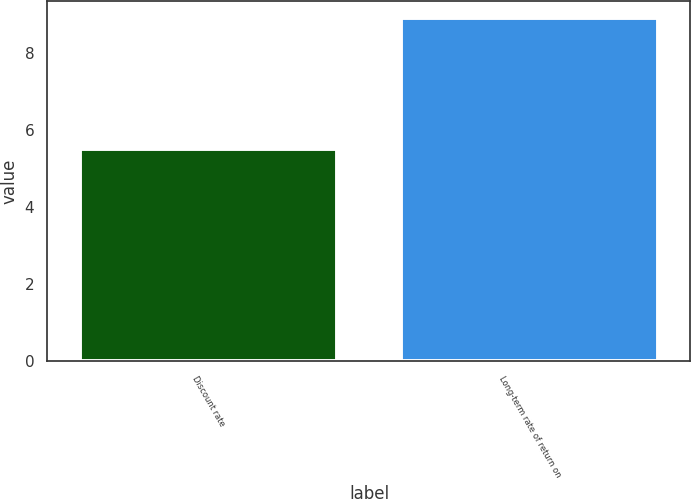Convert chart. <chart><loc_0><loc_0><loc_500><loc_500><bar_chart><fcel>Discount rate<fcel>Long-term rate of return on<nl><fcel>5.5<fcel>8.9<nl></chart> 